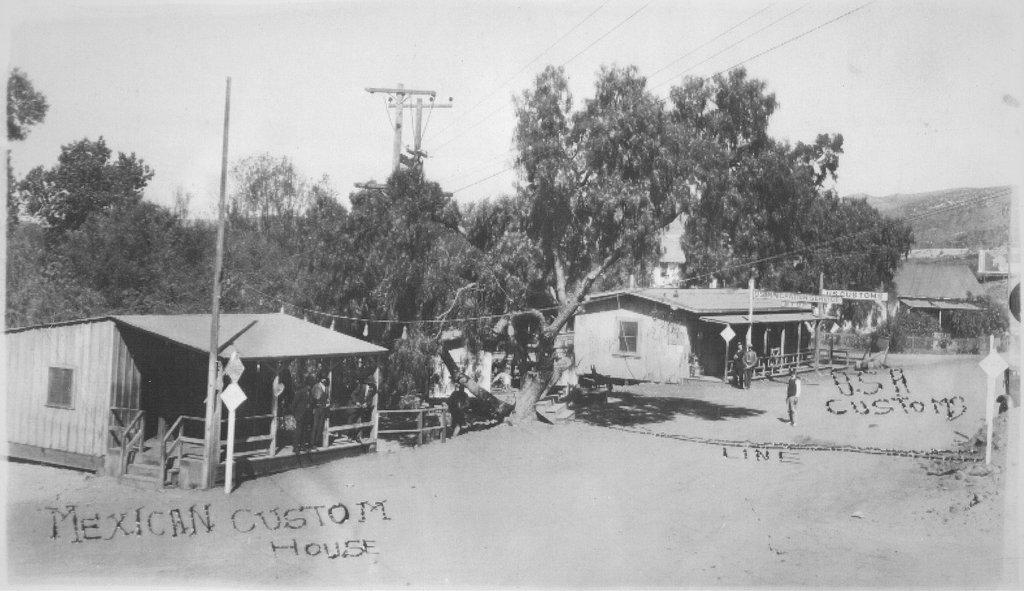What type of structures can be seen in the image? There are houses in the image. What else can be seen in the image besides houses? There are poles, trees, wires, and persons standing on the ground in the image. What is the background of the image? The sky is visible in the background of the image. What type of selection process is being conducted by the trees in the image? There is no selection process being conducted by the trees in the image; they are simply trees. 